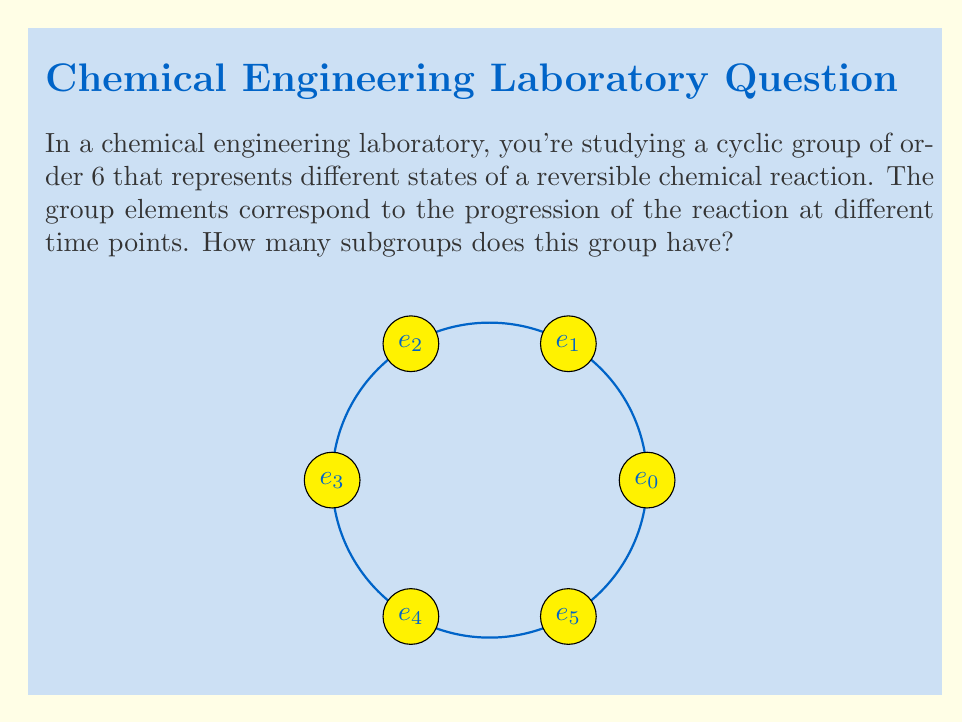What is the answer to this math problem? Let's approach this step-by-step:

1) First, recall that a cyclic group of order 6 is isomorphic to $\mathbb{Z}_6$, the group of integers modulo 6.

2) The number of subgroups in a cyclic group is equal to the number of divisors of the group's order. So, we need to find the divisors of 6.

3) The divisors of 6 are: 1, 2, 3, and 6.

4) Now, let's identify these subgroups:
   - The trivial subgroup $\{e_0\}$ (order 1)
   - $\{e_0, e_3\}$ (order 2)
   - $\{e_0, e_2, e_4\}$ (order 3)
   - The entire group $\{e_0, e_1, e_2, e_3, e_4, e_5\}$ (order 6)

5) We can verify this using Lagrange's theorem, which states that the order of a subgroup must divide the order of the group.

6) Therefore, the number of subgroups is equal to the number of divisors of 6, which is 4.

This result is particularly relevant in chemical engineering as it represents the number of distinct cyclic processes that can occur within the overall reaction, each corresponding to a different time scale or stage of the reaction.
Answer: 4 subgroups 